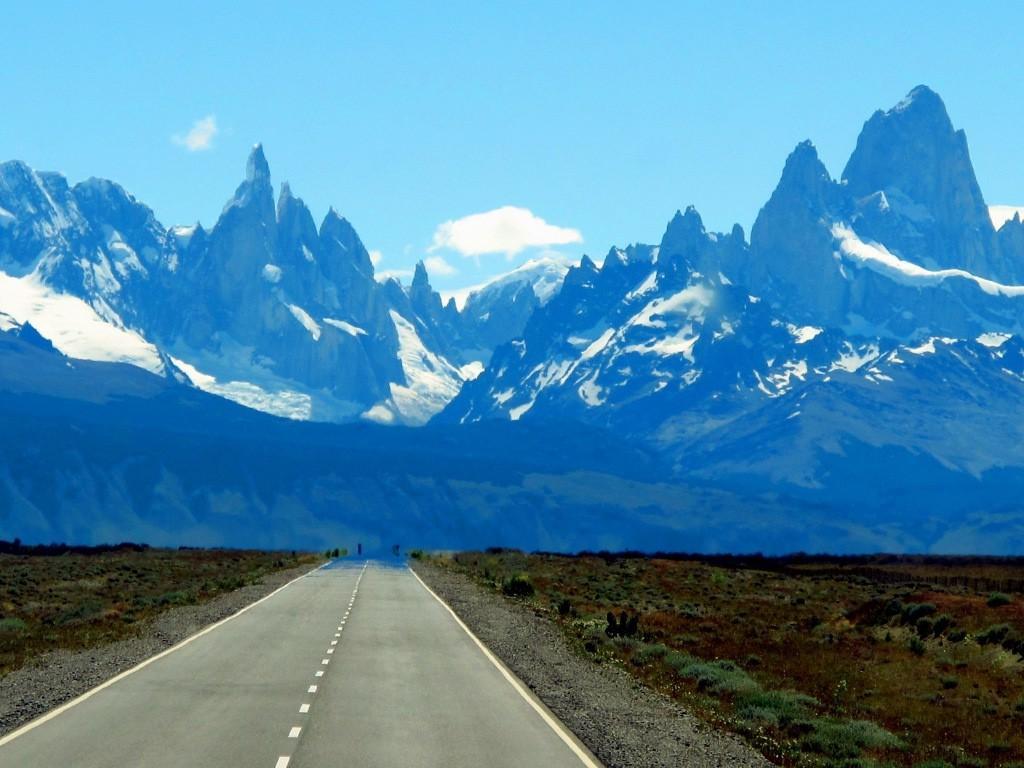Can you describe this image briefly? In this picture we can see snow mountains. At the bottom there is a road, beside that we can see the grass and plants. At the top we can see the sky and clouds. 